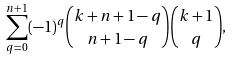Convert formula to latex. <formula><loc_0><loc_0><loc_500><loc_500>\sum _ { q = 0 } ^ { n + 1 } ( - 1 ) ^ { q } \binom { k + n + 1 - q } { n + 1 - q } \binom { k + 1 } { q } , \\</formula> 